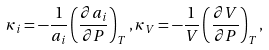Convert formula to latex. <formula><loc_0><loc_0><loc_500><loc_500>\kappa _ { i } = - \frac { 1 } { a _ { i } } \left ( \frac { \partial a _ { i } } { \partial P } \right ) _ { T } , \kappa _ { V } = - \frac { 1 } { V } \left ( \frac { \partial V } { \partial P } \right ) _ { T } ,</formula> 